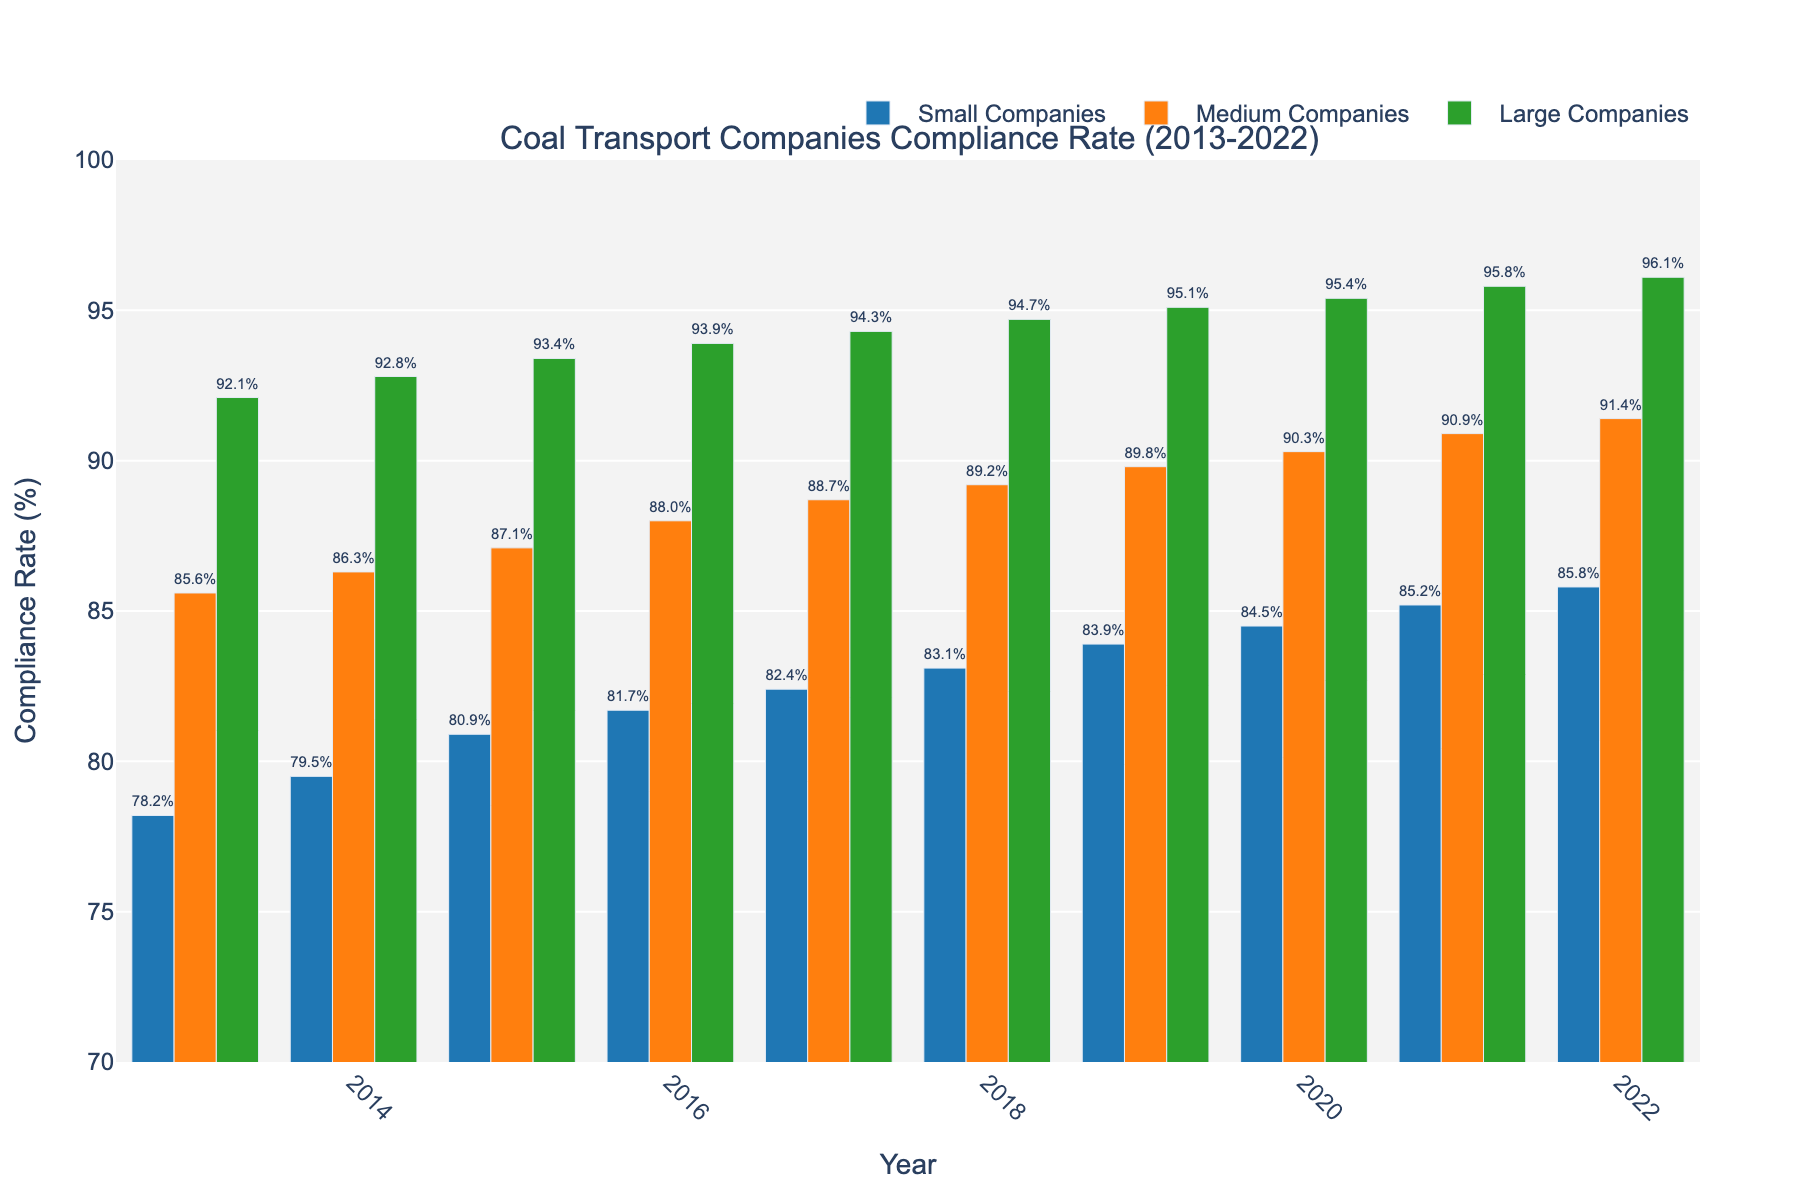What was the compliance rate for small companies in 2016? Look at the bar representing small companies in the year 2016. Note the compliance rate displayed on or next to the bar.
Answer: 81.7% Which type of company had the highest compliance rate in 2020? Compare the heights of the bars for small, medium, and large companies for the year 2020. The tallest bar represents the highest compliance rate.
Answer: Large Companies How did the compliance rate for medium companies change from 2014 to 2018? Find the compliance rates for medium companies in 2014 and 2018, then subtract the 2014 value from the 2018 value to find the change.
Answer: 89.2 - 86.3 = 2.9% What's the average compliance rate for large companies from 2018 to 2022? Sum the compliance rates for large companies from 2018 to 2022, then divide by the number of years (5) to find the average. Calculation: (94.7 + 95.1 + 95.4 + 95.8 + 96.1)/5
Answer: 95.42% Which year had the smallest difference in compliance rates between small and large companies? Calculate the differences in compliance rates for each year between small and large companies, then find the year with the smallest difference.
Answer: 2022 By how much did the compliance rate for small companies increase from 2013 to 2022? Find the compliance rates for small companies in 2013 and 2022, then subtract the 2013 value from the 2022 value to find the increase.
Answer: 85.8 - 78.2 = 7.6% What trend can be observed in the compliance rates of medium companies over the decade? Look at the bars for medium companies from 2013 to 2022 and note the general direction of the heights.
Answer: Increasing trend Did any type of company have a compliance rate below 80% at any point in the past decade? Scan the bars for each company type from 2013 to 2022 and check if any values fall below 80%.
Answer: Yes, Small Companies in 2013 and 2014 